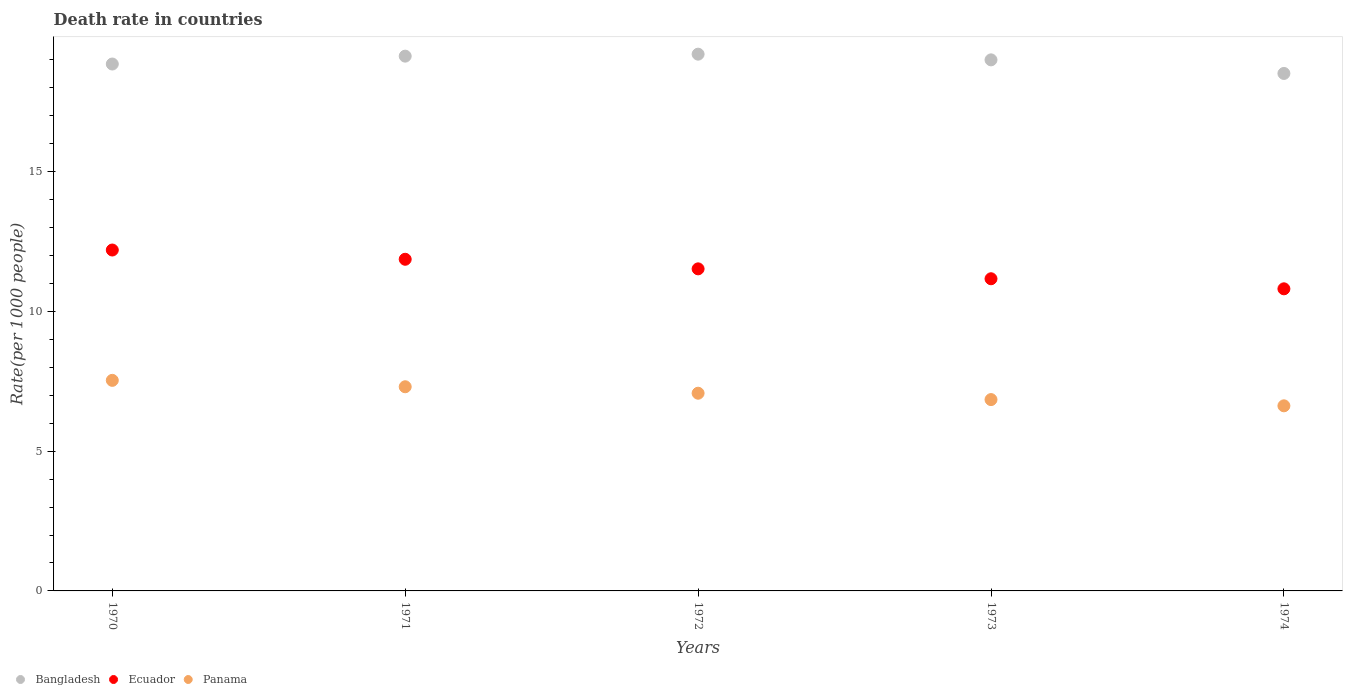How many different coloured dotlines are there?
Offer a terse response. 3. What is the death rate in Bangladesh in 1971?
Make the answer very short. 19.13. Across all years, what is the maximum death rate in Ecuador?
Make the answer very short. 12.2. Across all years, what is the minimum death rate in Ecuador?
Your answer should be very brief. 10.81. In which year was the death rate in Ecuador minimum?
Make the answer very short. 1974. What is the total death rate in Ecuador in the graph?
Ensure brevity in your answer.  57.56. What is the difference between the death rate in Bangladesh in 1973 and that in 1974?
Ensure brevity in your answer.  0.49. What is the difference between the death rate in Ecuador in 1971 and the death rate in Panama in 1974?
Offer a terse response. 5.24. What is the average death rate in Bangladesh per year?
Provide a short and direct response. 18.94. In the year 1974, what is the difference between the death rate in Bangladesh and death rate in Ecuador?
Ensure brevity in your answer.  7.71. What is the ratio of the death rate in Bangladesh in 1970 to that in 1971?
Make the answer very short. 0.99. What is the difference between the highest and the second highest death rate in Ecuador?
Provide a short and direct response. 0.33. What is the difference between the highest and the lowest death rate in Ecuador?
Offer a very short reply. 1.39. Does the death rate in Ecuador monotonically increase over the years?
Make the answer very short. No. Is the death rate in Bangladesh strictly greater than the death rate in Ecuador over the years?
Provide a succinct answer. Yes. How many dotlines are there?
Keep it short and to the point. 3. What is the difference between two consecutive major ticks on the Y-axis?
Give a very brief answer. 5. Does the graph contain any zero values?
Give a very brief answer. No. Where does the legend appear in the graph?
Ensure brevity in your answer.  Bottom left. How many legend labels are there?
Provide a short and direct response. 3. What is the title of the graph?
Offer a terse response. Death rate in countries. What is the label or title of the X-axis?
Make the answer very short. Years. What is the label or title of the Y-axis?
Provide a succinct answer. Rate(per 1000 people). What is the Rate(per 1000 people) in Bangladesh in 1970?
Your response must be concise. 18.85. What is the Rate(per 1000 people) in Ecuador in 1970?
Keep it short and to the point. 12.2. What is the Rate(per 1000 people) of Panama in 1970?
Ensure brevity in your answer.  7.53. What is the Rate(per 1000 people) in Bangladesh in 1971?
Provide a short and direct response. 19.13. What is the Rate(per 1000 people) of Ecuador in 1971?
Offer a very short reply. 11.87. What is the Rate(per 1000 people) in Panama in 1971?
Offer a very short reply. 7.3. What is the Rate(per 1000 people) of Bangladesh in 1972?
Offer a terse response. 19.2. What is the Rate(per 1000 people) in Ecuador in 1972?
Provide a short and direct response. 11.52. What is the Rate(per 1000 people) in Panama in 1972?
Provide a short and direct response. 7.07. What is the Rate(per 1000 people) of Bangladesh in 1973?
Your answer should be compact. 19. What is the Rate(per 1000 people) in Ecuador in 1973?
Your answer should be compact. 11.17. What is the Rate(per 1000 people) in Panama in 1973?
Your answer should be compact. 6.84. What is the Rate(per 1000 people) of Bangladesh in 1974?
Give a very brief answer. 18.51. What is the Rate(per 1000 people) in Ecuador in 1974?
Your answer should be compact. 10.81. What is the Rate(per 1000 people) of Panama in 1974?
Give a very brief answer. 6.62. Across all years, what is the maximum Rate(per 1000 people) of Bangladesh?
Provide a succinct answer. 19.2. Across all years, what is the maximum Rate(per 1000 people) in Ecuador?
Offer a terse response. 12.2. Across all years, what is the maximum Rate(per 1000 people) in Panama?
Ensure brevity in your answer.  7.53. Across all years, what is the minimum Rate(per 1000 people) in Bangladesh?
Your answer should be very brief. 18.51. Across all years, what is the minimum Rate(per 1000 people) in Ecuador?
Your answer should be very brief. 10.81. Across all years, what is the minimum Rate(per 1000 people) of Panama?
Your answer should be compact. 6.62. What is the total Rate(per 1000 people) of Bangladesh in the graph?
Offer a very short reply. 94.7. What is the total Rate(per 1000 people) in Ecuador in the graph?
Offer a terse response. 57.56. What is the total Rate(per 1000 people) in Panama in the graph?
Your answer should be compact. 35.38. What is the difference between the Rate(per 1000 people) in Bangladesh in 1970 and that in 1971?
Your response must be concise. -0.28. What is the difference between the Rate(per 1000 people) in Ecuador in 1970 and that in 1971?
Your answer should be very brief. 0.33. What is the difference between the Rate(per 1000 people) of Panama in 1970 and that in 1971?
Provide a succinct answer. 0.23. What is the difference between the Rate(per 1000 people) in Bangladesh in 1970 and that in 1972?
Ensure brevity in your answer.  -0.35. What is the difference between the Rate(per 1000 people) of Ecuador in 1970 and that in 1972?
Offer a very short reply. 0.67. What is the difference between the Rate(per 1000 people) in Panama in 1970 and that in 1972?
Your response must be concise. 0.46. What is the difference between the Rate(per 1000 people) in Bangladesh in 1970 and that in 1973?
Your answer should be compact. -0.15. What is the difference between the Rate(per 1000 people) of Ecuador in 1970 and that in 1973?
Keep it short and to the point. 1.03. What is the difference between the Rate(per 1000 people) in Panama in 1970 and that in 1973?
Offer a terse response. 0.69. What is the difference between the Rate(per 1000 people) of Bangladesh in 1970 and that in 1974?
Provide a short and direct response. 0.34. What is the difference between the Rate(per 1000 people) in Ecuador in 1970 and that in 1974?
Offer a terse response. 1.39. What is the difference between the Rate(per 1000 people) in Panama in 1970 and that in 1974?
Keep it short and to the point. 0.91. What is the difference between the Rate(per 1000 people) of Bangladesh in 1971 and that in 1972?
Your response must be concise. -0.07. What is the difference between the Rate(per 1000 people) of Ecuador in 1971 and that in 1972?
Offer a very short reply. 0.34. What is the difference between the Rate(per 1000 people) of Panama in 1971 and that in 1972?
Keep it short and to the point. 0.23. What is the difference between the Rate(per 1000 people) of Bangladesh in 1971 and that in 1973?
Keep it short and to the point. 0.13. What is the difference between the Rate(per 1000 people) of Ecuador in 1971 and that in 1973?
Ensure brevity in your answer.  0.7. What is the difference between the Rate(per 1000 people) in Panama in 1971 and that in 1973?
Your response must be concise. 0.46. What is the difference between the Rate(per 1000 people) in Bangladesh in 1971 and that in 1974?
Offer a very short reply. 0.62. What is the difference between the Rate(per 1000 people) of Ecuador in 1971 and that in 1974?
Give a very brief answer. 1.06. What is the difference between the Rate(per 1000 people) in Panama in 1971 and that in 1974?
Give a very brief answer. 0.68. What is the difference between the Rate(per 1000 people) of Bangladesh in 1972 and that in 1973?
Ensure brevity in your answer.  0.2. What is the difference between the Rate(per 1000 people) in Ecuador in 1972 and that in 1973?
Keep it short and to the point. 0.35. What is the difference between the Rate(per 1000 people) of Panama in 1972 and that in 1973?
Provide a short and direct response. 0.23. What is the difference between the Rate(per 1000 people) of Bangladesh in 1972 and that in 1974?
Your answer should be compact. 0.69. What is the difference between the Rate(per 1000 people) of Ecuador in 1972 and that in 1974?
Provide a short and direct response. 0.71. What is the difference between the Rate(per 1000 people) of Panama in 1972 and that in 1974?
Make the answer very short. 0.45. What is the difference between the Rate(per 1000 people) in Bangladesh in 1973 and that in 1974?
Keep it short and to the point. 0.49. What is the difference between the Rate(per 1000 people) of Ecuador in 1973 and that in 1974?
Your answer should be compact. 0.36. What is the difference between the Rate(per 1000 people) in Panama in 1973 and that in 1974?
Ensure brevity in your answer.  0.22. What is the difference between the Rate(per 1000 people) of Bangladesh in 1970 and the Rate(per 1000 people) of Ecuador in 1971?
Give a very brief answer. 6.99. What is the difference between the Rate(per 1000 people) of Bangladesh in 1970 and the Rate(per 1000 people) of Panama in 1971?
Your answer should be compact. 11.55. What is the difference between the Rate(per 1000 people) of Ecuador in 1970 and the Rate(per 1000 people) of Panama in 1971?
Give a very brief answer. 4.89. What is the difference between the Rate(per 1000 people) in Bangladesh in 1970 and the Rate(per 1000 people) in Ecuador in 1972?
Offer a very short reply. 7.33. What is the difference between the Rate(per 1000 people) in Bangladesh in 1970 and the Rate(per 1000 people) in Panama in 1972?
Keep it short and to the point. 11.78. What is the difference between the Rate(per 1000 people) in Ecuador in 1970 and the Rate(per 1000 people) in Panama in 1972?
Offer a terse response. 5.12. What is the difference between the Rate(per 1000 people) of Bangladesh in 1970 and the Rate(per 1000 people) of Ecuador in 1973?
Your answer should be compact. 7.68. What is the difference between the Rate(per 1000 people) of Bangladesh in 1970 and the Rate(per 1000 people) of Panama in 1973?
Your answer should be very brief. 12.01. What is the difference between the Rate(per 1000 people) in Ecuador in 1970 and the Rate(per 1000 people) in Panama in 1973?
Your answer should be compact. 5.35. What is the difference between the Rate(per 1000 people) in Bangladesh in 1970 and the Rate(per 1000 people) in Ecuador in 1974?
Provide a short and direct response. 8.04. What is the difference between the Rate(per 1000 people) of Bangladesh in 1970 and the Rate(per 1000 people) of Panama in 1974?
Provide a short and direct response. 12.23. What is the difference between the Rate(per 1000 people) of Ecuador in 1970 and the Rate(per 1000 people) of Panama in 1974?
Give a very brief answer. 5.57. What is the difference between the Rate(per 1000 people) in Bangladesh in 1971 and the Rate(per 1000 people) in Ecuador in 1972?
Your answer should be compact. 7.61. What is the difference between the Rate(per 1000 people) of Bangladesh in 1971 and the Rate(per 1000 people) of Panama in 1972?
Ensure brevity in your answer.  12.06. What is the difference between the Rate(per 1000 people) in Ecuador in 1971 and the Rate(per 1000 people) in Panama in 1972?
Your answer should be compact. 4.79. What is the difference between the Rate(per 1000 people) of Bangladesh in 1971 and the Rate(per 1000 people) of Ecuador in 1973?
Keep it short and to the point. 7.96. What is the difference between the Rate(per 1000 people) in Bangladesh in 1971 and the Rate(per 1000 people) in Panama in 1973?
Offer a very short reply. 12.29. What is the difference between the Rate(per 1000 people) in Ecuador in 1971 and the Rate(per 1000 people) in Panama in 1973?
Offer a terse response. 5.02. What is the difference between the Rate(per 1000 people) in Bangladesh in 1971 and the Rate(per 1000 people) in Ecuador in 1974?
Offer a terse response. 8.32. What is the difference between the Rate(per 1000 people) in Bangladesh in 1971 and the Rate(per 1000 people) in Panama in 1974?
Provide a succinct answer. 12.51. What is the difference between the Rate(per 1000 people) of Ecuador in 1971 and the Rate(per 1000 people) of Panama in 1974?
Provide a succinct answer. 5.24. What is the difference between the Rate(per 1000 people) in Bangladesh in 1972 and the Rate(per 1000 people) in Ecuador in 1973?
Your answer should be very brief. 8.04. What is the difference between the Rate(per 1000 people) of Bangladesh in 1972 and the Rate(per 1000 people) of Panama in 1973?
Your response must be concise. 12.36. What is the difference between the Rate(per 1000 people) of Ecuador in 1972 and the Rate(per 1000 people) of Panama in 1973?
Provide a succinct answer. 4.68. What is the difference between the Rate(per 1000 people) of Bangladesh in 1972 and the Rate(per 1000 people) of Ecuador in 1974?
Offer a very short reply. 8.39. What is the difference between the Rate(per 1000 people) in Bangladesh in 1972 and the Rate(per 1000 people) in Panama in 1974?
Offer a terse response. 12.58. What is the difference between the Rate(per 1000 people) in Ecuador in 1972 and the Rate(per 1000 people) in Panama in 1974?
Your answer should be compact. 4.9. What is the difference between the Rate(per 1000 people) in Bangladesh in 1973 and the Rate(per 1000 people) in Ecuador in 1974?
Your response must be concise. 8.19. What is the difference between the Rate(per 1000 people) of Bangladesh in 1973 and the Rate(per 1000 people) of Panama in 1974?
Ensure brevity in your answer.  12.38. What is the difference between the Rate(per 1000 people) in Ecuador in 1973 and the Rate(per 1000 people) in Panama in 1974?
Your answer should be very brief. 4.55. What is the average Rate(per 1000 people) of Bangladesh per year?
Your answer should be compact. 18.94. What is the average Rate(per 1000 people) in Ecuador per year?
Your answer should be compact. 11.51. What is the average Rate(per 1000 people) of Panama per year?
Offer a terse response. 7.08. In the year 1970, what is the difference between the Rate(per 1000 people) of Bangladesh and Rate(per 1000 people) of Ecuador?
Offer a terse response. 6.65. In the year 1970, what is the difference between the Rate(per 1000 people) of Bangladesh and Rate(per 1000 people) of Panama?
Provide a succinct answer. 11.32. In the year 1970, what is the difference between the Rate(per 1000 people) of Ecuador and Rate(per 1000 people) of Panama?
Ensure brevity in your answer.  4.66. In the year 1971, what is the difference between the Rate(per 1000 people) of Bangladesh and Rate(per 1000 people) of Ecuador?
Your response must be concise. 7.27. In the year 1971, what is the difference between the Rate(per 1000 people) of Bangladesh and Rate(per 1000 people) of Panama?
Offer a terse response. 11.83. In the year 1971, what is the difference between the Rate(per 1000 people) of Ecuador and Rate(per 1000 people) of Panama?
Provide a short and direct response. 4.56. In the year 1972, what is the difference between the Rate(per 1000 people) in Bangladesh and Rate(per 1000 people) in Ecuador?
Your response must be concise. 7.68. In the year 1972, what is the difference between the Rate(per 1000 people) in Bangladesh and Rate(per 1000 people) in Panama?
Your answer should be very brief. 12.13. In the year 1972, what is the difference between the Rate(per 1000 people) in Ecuador and Rate(per 1000 people) in Panama?
Ensure brevity in your answer.  4.45. In the year 1973, what is the difference between the Rate(per 1000 people) of Bangladesh and Rate(per 1000 people) of Ecuador?
Ensure brevity in your answer.  7.83. In the year 1973, what is the difference between the Rate(per 1000 people) in Bangladesh and Rate(per 1000 people) in Panama?
Provide a short and direct response. 12.15. In the year 1973, what is the difference between the Rate(per 1000 people) of Ecuador and Rate(per 1000 people) of Panama?
Keep it short and to the point. 4.32. In the year 1974, what is the difference between the Rate(per 1000 people) of Bangladesh and Rate(per 1000 people) of Ecuador?
Keep it short and to the point. 7.71. In the year 1974, what is the difference between the Rate(per 1000 people) of Bangladesh and Rate(per 1000 people) of Panama?
Your answer should be compact. 11.89. In the year 1974, what is the difference between the Rate(per 1000 people) in Ecuador and Rate(per 1000 people) in Panama?
Your answer should be compact. 4.19. What is the ratio of the Rate(per 1000 people) in Bangladesh in 1970 to that in 1971?
Give a very brief answer. 0.99. What is the ratio of the Rate(per 1000 people) of Ecuador in 1970 to that in 1971?
Ensure brevity in your answer.  1.03. What is the ratio of the Rate(per 1000 people) of Panama in 1970 to that in 1971?
Offer a terse response. 1.03. What is the ratio of the Rate(per 1000 people) in Bangladesh in 1970 to that in 1972?
Provide a succinct answer. 0.98. What is the ratio of the Rate(per 1000 people) in Ecuador in 1970 to that in 1972?
Ensure brevity in your answer.  1.06. What is the ratio of the Rate(per 1000 people) in Panama in 1970 to that in 1972?
Your response must be concise. 1.06. What is the ratio of the Rate(per 1000 people) in Ecuador in 1970 to that in 1973?
Provide a short and direct response. 1.09. What is the ratio of the Rate(per 1000 people) of Panama in 1970 to that in 1973?
Your answer should be very brief. 1.1. What is the ratio of the Rate(per 1000 people) in Bangladesh in 1970 to that in 1974?
Ensure brevity in your answer.  1.02. What is the ratio of the Rate(per 1000 people) of Ecuador in 1970 to that in 1974?
Keep it short and to the point. 1.13. What is the ratio of the Rate(per 1000 people) of Panama in 1970 to that in 1974?
Provide a short and direct response. 1.14. What is the ratio of the Rate(per 1000 people) of Ecuador in 1971 to that in 1972?
Provide a short and direct response. 1.03. What is the ratio of the Rate(per 1000 people) in Panama in 1971 to that in 1972?
Your answer should be very brief. 1.03. What is the ratio of the Rate(per 1000 people) of Ecuador in 1971 to that in 1973?
Your response must be concise. 1.06. What is the ratio of the Rate(per 1000 people) of Panama in 1971 to that in 1973?
Offer a terse response. 1.07. What is the ratio of the Rate(per 1000 people) in Bangladesh in 1971 to that in 1974?
Provide a succinct answer. 1.03. What is the ratio of the Rate(per 1000 people) of Ecuador in 1971 to that in 1974?
Your answer should be very brief. 1.1. What is the ratio of the Rate(per 1000 people) in Panama in 1971 to that in 1974?
Keep it short and to the point. 1.1. What is the ratio of the Rate(per 1000 people) of Bangladesh in 1972 to that in 1973?
Ensure brevity in your answer.  1.01. What is the ratio of the Rate(per 1000 people) of Ecuador in 1972 to that in 1973?
Offer a very short reply. 1.03. What is the ratio of the Rate(per 1000 people) of Bangladesh in 1972 to that in 1974?
Your answer should be very brief. 1.04. What is the ratio of the Rate(per 1000 people) of Ecuador in 1972 to that in 1974?
Provide a short and direct response. 1.07. What is the ratio of the Rate(per 1000 people) in Panama in 1972 to that in 1974?
Provide a short and direct response. 1.07. What is the ratio of the Rate(per 1000 people) in Bangladesh in 1973 to that in 1974?
Provide a succinct answer. 1.03. What is the ratio of the Rate(per 1000 people) of Ecuador in 1973 to that in 1974?
Make the answer very short. 1.03. What is the ratio of the Rate(per 1000 people) in Panama in 1973 to that in 1974?
Give a very brief answer. 1.03. What is the difference between the highest and the second highest Rate(per 1000 people) of Bangladesh?
Provide a short and direct response. 0.07. What is the difference between the highest and the second highest Rate(per 1000 people) in Ecuador?
Your response must be concise. 0.33. What is the difference between the highest and the second highest Rate(per 1000 people) of Panama?
Your answer should be compact. 0.23. What is the difference between the highest and the lowest Rate(per 1000 people) of Bangladesh?
Your answer should be compact. 0.69. What is the difference between the highest and the lowest Rate(per 1000 people) in Ecuador?
Provide a short and direct response. 1.39. What is the difference between the highest and the lowest Rate(per 1000 people) in Panama?
Your response must be concise. 0.91. 